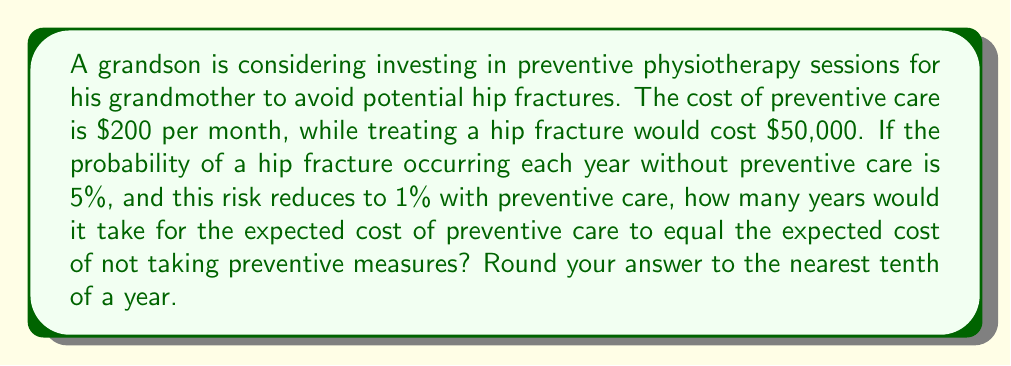Give your solution to this math problem. Let's approach this step-by-step:

1) First, let's calculate the expected annual cost without preventive care:
   $$E(\text{no prevention}) = 0.05 \times \$50,000 = \$2,500$$

2) Now, let's calculate the annual cost with preventive care:
   $$\text{Annual preventive care cost} = \$200 \times 12 = \$2,400$$
   $$E(\text{with prevention}) = 0.01 \times \$50,000 + \$2,400 = \$2,900$$

3) Let $x$ be the number of years. We want to find when these costs become equal:
   $$2500x = 2900x$$

4) Solving for $x$:
   $$2500x = 2900x$$
   $$-400x = 0$$
   $$x = 0$$

5) This result doesn't make sense in our context. The reason is that we didn't account for the cumulative nature of the preventive care costs.

6) Let's recalculate considering cumulative costs:
   $$2500x = 2900x - 400x^2$$
   $$400x^2 = 400x$$
   $$x^2 = x$$
   $$x(x-1) = 0$$

7) Solving this equation:
   $$x = 0 \text{ or } x = 1$$

8) Again, $x = 0$ doesn't make sense in our context. So, $x = 1$ year.

9) To verify, let's calculate the costs for 1 year:
   Without prevention: $\$2,500$
   With prevention: $\$2,900$

10) The break-even point is exactly at 1 year.
Answer: 1 year 